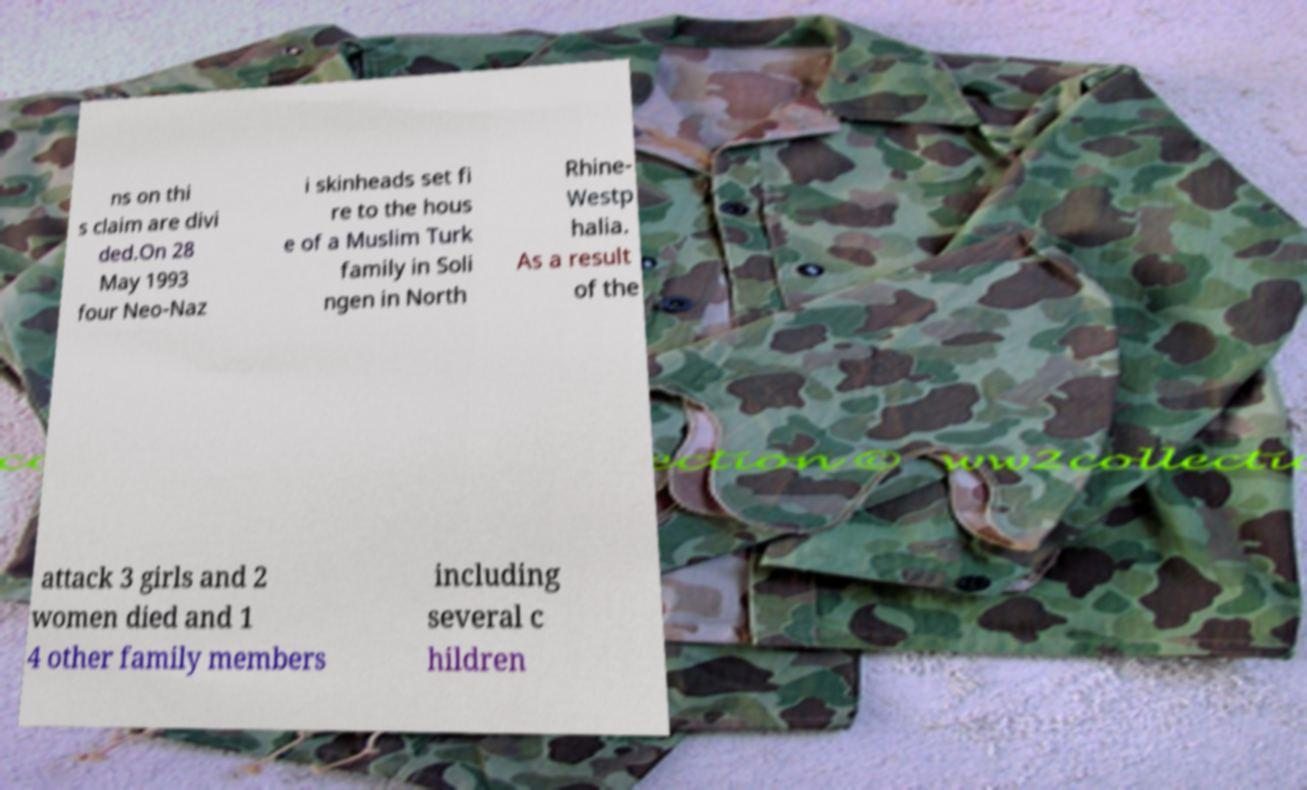I need the written content from this picture converted into text. Can you do that? ns on thi s claim are divi ded.On 28 May 1993 four Neo-Naz i skinheads set fi re to the hous e of a Muslim Turk family in Soli ngen in North Rhine- Westp halia. As a result of the attack 3 girls and 2 women died and 1 4 other family members including several c hildren 